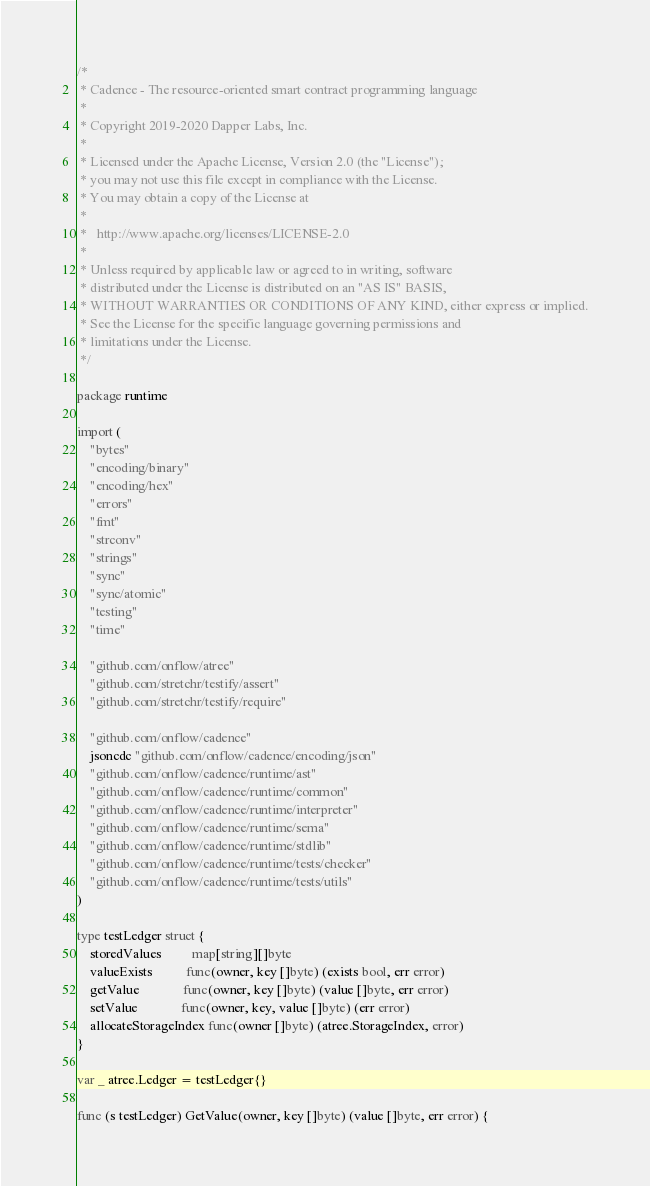Convert code to text. <code><loc_0><loc_0><loc_500><loc_500><_Go_>/*
 * Cadence - The resource-oriented smart contract programming language
 *
 * Copyright 2019-2020 Dapper Labs, Inc.
 *
 * Licensed under the Apache License, Version 2.0 (the "License");
 * you may not use this file except in compliance with the License.
 * You may obtain a copy of the License at
 *
 *   http://www.apache.org/licenses/LICENSE-2.0
 *
 * Unless required by applicable law or agreed to in writing, software
 * distributed under the License is distributed on an "AS IS" BASIS,
 * WITHOUT WARRANTIES OR CONDITIONS OF ANY KIND, either express or implied.
 * See the License for the specific language governing permissions and
 * limitations under the License.
 */

package runtime

import (
	"bytes"
	"encoding/binary"
	"encoding/hex"
	"errors"
	"fmt"
	"strconv"
	"strings"
	"sync"
	"sync/atomic"
	"testing"
	"time"

	"github.com/onflow/atree"
	"github.com/stretchr/testify/assert"
	"github.com/stretchr/testify/require"

	"github.com/onflow/cadence"
	jsoncdc "github.com/onflow/cadence/encoding/json"
	"github.com/onflow/cadence/runtime/ast"
	"github.com/onflow/cadence/runtime/common"
	"github.com/onflow/cadence/runtime/interpreter"
	"github.com/onflow/cadence/runtime/sema"
	"github.com/onflow/cadence/runtime/stdlib"
	"github.com/onflow/cadence/runtime/tests/checker"
	"github.com/onflow/cadence/runtime/tests/utils"
)

type testLedger struct {
	storedValues         map[string][]byte
	valueExists          func(owner, key []byte) (exists bool, err error)
	getValue             func(owner, key []byte) (value []byte, err error)
	setValue             func(owner, key, value []byte) (err error)
	allocateStorageIndex func(owner []byte) (atree.StorageIndex, error)
}

var _ atree.Ledger = testLedger{}

func (s testLedger) GetValue(owner, key []byte) (value []byte, err error) {</code> 